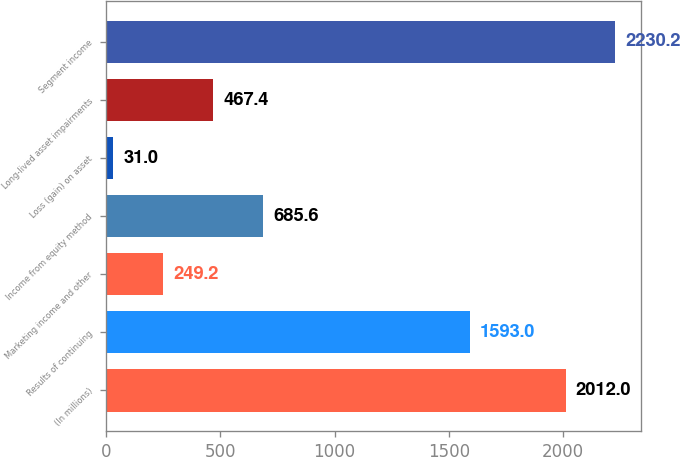Convert chart. <chart><loc_0><loc_0><loc_500><loc_500><bar_chart><fcel>(In millions)<fcel>Results of continuing<fcel>Marketing income and other<fcel>Income from equity method<fcel>Loss (gain) on asset<fcel>Long-lived asset impairments<fcel>Segment income<nl><fcel>2012<fcel>1593<fcel>249.2<fcel>685.6<fcel>31<fcel>467.4<fcel>2230.2<nl></chart> 